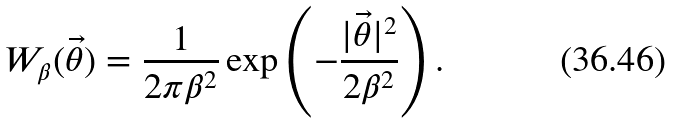Convert formula to latex. <formula><loc_0><loc_0><loc_500><loc_500>W _ { \beta } ( \vec { \theta } ) = \frac { 1 } { 2 \pi \beta ^ { 2 } } \exp \left ( - \frac { | \vec { \theta } | ^ { 2 } } { 2 \beta ^ { 2 } } \right ) .</formula> 